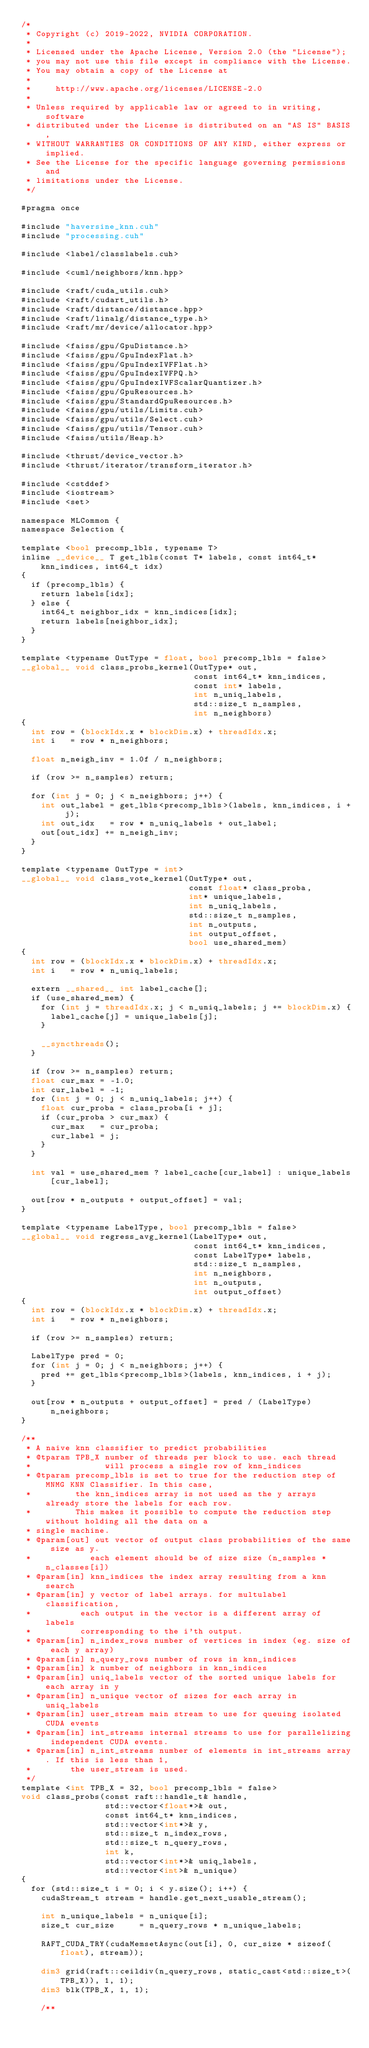<code> <loc_0><loc_0><loc_500><loc_500><_Cuda_>/*
 * Copyright (c) 2019-2022, NVIDIA CORPORATION.
 *
 * Licensed under the Apache License, Version 2.0 (the "License");
 * you may not use this file except in compliance with the License.
 * You may obtain a copy of the License at
 *
 *     http://www.apache.org/licenses/LICENSE-2.0
 *
 * Unless required by applicable law or agreed to in writing, software
 * distributed under the License is distributed on an "AS IS" BASIS,
 * WITHOUT WARRANTIES OR CONDITIONS OF ANY KIND, either express or implied.
 * See the License for the specific language governing permissions and
 * limitations under the License.
 */

#pragma once

#include "haversine_knn.cuh"
#include "processing.cuh"

#include <label/classlabels.cuh>

#include <cuml/neighbors/knn.hpp>

#include <raft/cuda_utils.cuh>
#include <raft/cudart_utils.h>
#include <raft/distance/distance.hpp>
#include <raft/linalg/distance_type.h>
#include <raft/mr/device/allocator.hpp>

#include <faiss/gpu/GpuDistance.h>
#include <faiss/gpu/GpuIndexFlat.h>
#include <faiss/gpu/GpuIndexIVFFlat.h>
#include <faiss/gpu/GpuIndexIVFPQ.h>
#include <faiss/gpu/GpuIndexIVFScalarQuantizer.h>
#include <faiss/gpu/GpuResources.h>
#include <faiss/gpu/StandardGpuResources.h>
#include <faiss/gpu/utils/Limits.cuh>
#include <faiss/gpu/utils/Select.cuh>
#include <faiss/gpu/utils/Tensor.cuh>
#include <faiss/utils/Heap.h>

#include <thrust/device_vector.h>
#include <thrust/iterator/transform_iterator.h>

#include <cstddef>
#include <iostream>
#include <set>

namespace MLCommon {
namespace Selection {

template <bool precomp_lbls, typename T>
inline __device__ T get_lbls(const T* labels, const int64_t* knn_indices, int64_t idx)
{
  if (precomp_lbls) {
    return labels[idx];
  } else {
    int64_t neighbor_idx = knn_indices[idx];
    return labels[neighbor_idx];
  }
}

template <typename OutType = float, bool precomp_lbls = false>
__global__ void class_probs_kernel(OutType* out,
                                   const int64_t* knn_indices,
                                   const int* labels,
                                   int n_uniq_labels,
                                   std::size_t n_samples,
                                   int n_neighbors)
{
  int row = (blockIdx.x * blockDim.x) + threadIdx.x;
  int i   = row * n_neighbors;

  float n_neigh_inv = 1.0f / n_neighbors;

  if (row >= n_samples) return;

  for (int j = 0; j < n_neighbors; j++) {
    int out_label = get_lbls<precomp_lbls>(labels, knn_indices, i + j);
    int out_idx   = row * n_uniq_labels + out_label;
    out[out_idx] += n_neigh_inv;
  }
}

template <typename OutType = int>
__global__ void class_vote_kernel(OutType* out,
                                  const float* class_proba,
                                  int* unique_labels,
                                  int n_uniq_labels,
                                  std::size_t n_samples,
                                  int n_outputs,
                                  int output_offset,
                                  bool use_shared_mem)
{
  int row = (blockIdx.x * blockDim.x) + threadIdx.x;
  int i   = row * n_uniq_labels;

  extern __shared__ int label_cache[];
  if (use_shared_mem) {
    for (int j = threadIdx.x; j < n_uniq_labels; j += blockDim.x) {
      label_cache[j] = unique_labels[j];
    }

    __syncthreads();
  }

  if (row >= n_samples) return;
  float cur_max = -1.0;
  int cur_label = -1;
  for (int j = 0; j < n_uniq_labels; j++) {
    float cur_proba = class_proba[i + j];
    if (cur_proba > cur_max) {
      cur_max   = cur_proba;
      cur_label = j;
    }
  }

  int val = use_shared_mem ? label_cache[cur_label] : unique_labels[cur_label];

  out[row * n_outputs + output_offset] = val;
}

template <typename LabelType, bool precomp_lbls = false>
__global__ void regress_avg_kernel(LabelType* out,
                                   const int64_t* knn_indices,
                                   const LabelType* labels,
                                   std::size_t n_samples,
                                   int n_neighbors,
                                   int n_outputs,
                                   int output_offset)
{
  int row = (blockIdx.x * blockDim.x) + threadIdx.x;
  int i   = row * n_neighbors;

  if (row >= n_samples) return;

  LabelType pred = 0;
  for (int j = 0; j < n_neighbors; j++) {
    pred += get_lbls<precomp_lbls>(labels, knn_indices, i + j);
  }

  out[row * n_outputs + output_offset] = pred / (LabelType)n_neighbors;
}

/**
 * A naive knn classifier to predict probabilities
 * @tparam TPB_X number of threads per block to use. each thread
 *               will process a single row of knn_indices
 * @tparam precomp_lbls is set to true for the reduction step of MNMG KNN Classifier. In this case,
 *         the knn_indices array is not used as the y arrays already store the labels for each row.
 *         This makes it possible to compute the reduction step without holding all the data on a
 * single machine.
 * @param[out] out vector of output class probabilities of the same size as y.
 *            each element should be of size size (n_samples * n_classes[i])
 * @param[in] knn_indices the index array resulting from a knn search
 * @param[in] y vector of label arrays. for multulabel classification,
 *          each output in the vector is a different array of labels
 *          corresponding to the i'th output.
 * @param[in] n_index_rows number of vertices in index (eg. size of each y array)
 * @param[in] n_query_rows number of rows in knn_indices
 * @param[in] k number of neighbors in knn_indices
 * @param[in] uniq_labels vector of the sorted unique labels for each array in y
 * @param[in] n_unique vector of sizes for each array in uniq_labels
 * @param[in] user_stream main stream to use for queuing isolated CUDA events
 * @param[in] int_streams internal streams to use for parallelizing independent CUDA events.
 * @param[in] n_int_streams number of elements in int_streams array. If this is less than 1,
 *        the user_stream is used.
 */
template <int TPB_X = 32, bool precomp_lbls = false>
void class_probs(const raft::handle_t& handle,
                 std::vector<float*>& out,
                 const int64_t* knn_indices,
                 std::vector<int*>& y,
                 std::size_t n_index_rows,
                 std::size_t n_query_rows,
                 int k,
                 std::vector<int*>& uniq_labels,
                 std::vector<int>& n_unique)
{
  for (std::size_t i = 0; i < y.size(); i++) {
    cudaStream_t stream = handle.get_next_usable_stream();

    int n_unique_labels = n_unique[i];
    size_t cur_size     = n_query_rows * n_unique_labels;

    RAFT_CUDA_TRY(cudaMemsetAsync(out[i], 0, cur_size * sizeof(float), stream));

    dim3 grid(raft::ceildiv(n_query_rows, static_cast<std::size_t>(TPB_X)), 1, 1);
    dim3 blk(TPB_X, 1, 1);

    /**</code> 